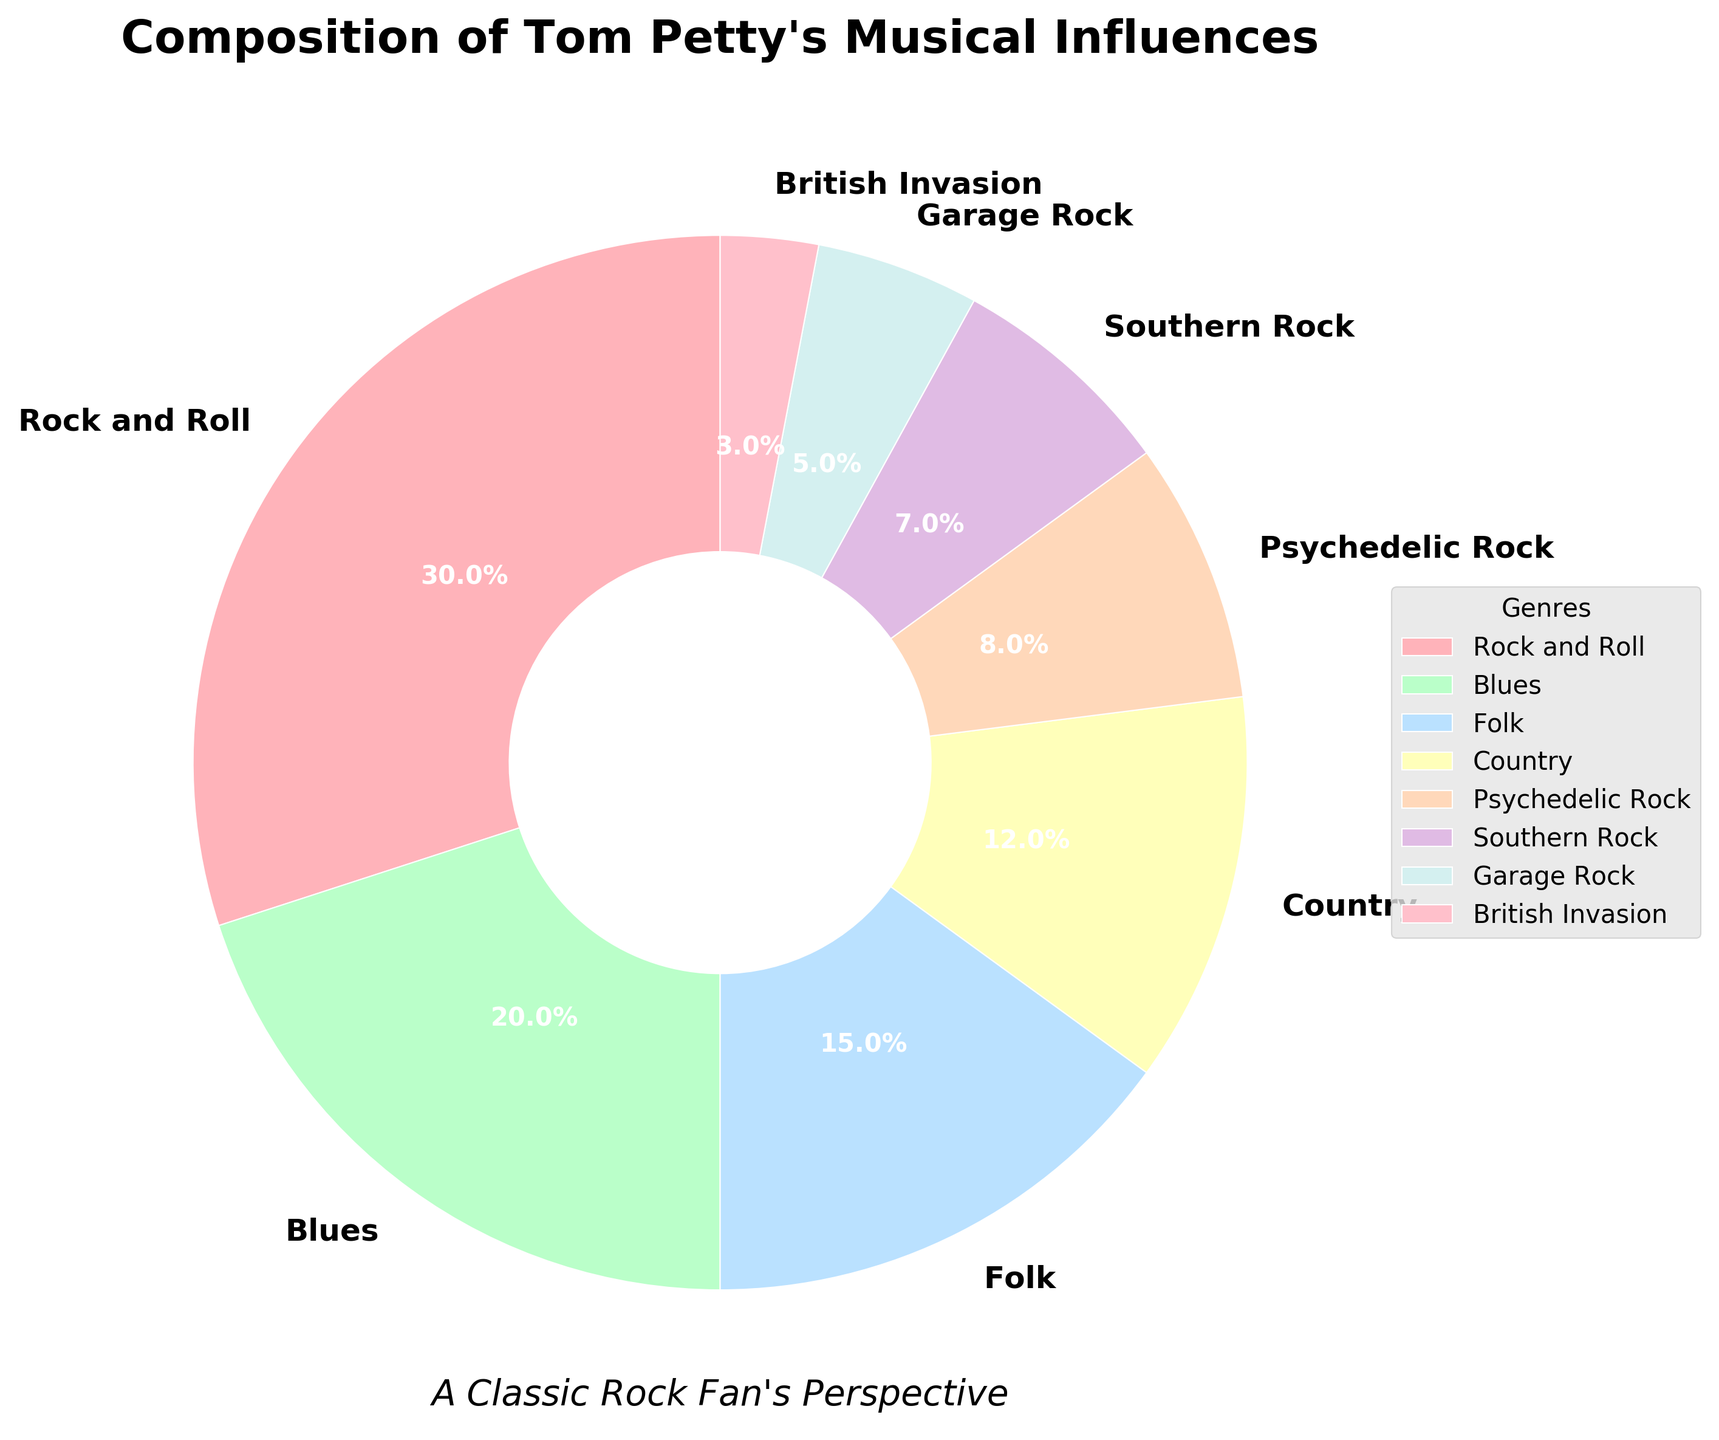What are the two most prominent influences on Tom Petty's musical style, and what is their combined percentage? The two most prominent influences are mentioned in the legend, and their corresponding segments in the pie chart are the largest. These are "Rock and Roll" with 30% and "Blues" with 20%. Adding these percentages together gives 30% + 20% = 50%.
Answer: Rock and Roll and Blues; 50% How much more influence does Rock and Roll have compared to the least influential genre? The largest segment is "Rock and Roll" at 30%, and the smallest segment is "British Invasion" at 3%. The difference is 30% - 3% = 27%.
Answer: 27% Which genres have a combined influence of over 50% when summed together? By reviewing the pie chart, start summing the largest segments until the combined total exceeds 50%. Rock and Roll (30%) + Blues (20%) = 50%, so adding any other genre will exceed 50%.
Answer: Rock and Roll and Blues What is the visual representation (color) for the "Psychedelic Rock" genre? By observing the pie chart and matching the genre labels with their corresponding colors, "Psychedelic Rock" is represented in a light orange (close to a peach tint).
Answer: Light orange (peach tint) How does the influence of Folk compare to Country in terms of percentage difference? The pie chart shows Folk at 15% and Country at 12%. The difference is calculated as 15% - 12% = 3%.
Answer: 3% By how much does the combined influence of Southern Rock and Garage Rock fall short of that of Rock and Roll? Southern Rock is 7% and Garage Rock is 5%. Combined, they account for 7% + 5% = 12%. Rock and Roll is 30%, so the shortfall is 30% - 12% = 18%.
Answer: 18% What is the average percentage of influence for all the genres shown in the chart? To find the average, sum all the percentages and divide by the number of genres. (30% + 20% + 15% + 12% + 8% + 7% + 5% + 3%) = 100%, 100% / 8 = 12.5%.
Answer: 12.5% Which genre is represented by the smallest segment in the pie chart? By examining the pie chart, identify the smallest segment which corresponds to "British Invasion" with 3%.
Answer: British Invasion How many genres have an influence of less than 10% on Tom Petty's musical style? By looking at the pie chart, count the segments that represent less than 10%. These are Psychedelic Rock (8%), Southern Rock (7%), Garage Rock (5%), and British Invasion (3%). So, there are 4 genres.
Answer: 4 